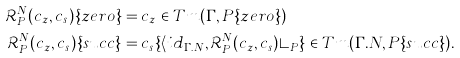<formula> <loc_0><loc_0><loc_500><loc_500>\mathcal { R } ^ { N } _ { P } ( c _ { z } , c _ { s } ) \{ z e r o \} & = c _ { z } \in T m ( \Gamma , P \{ z e r o \} ) \\ \mathcal { R } ^ { N } _ { P } ( c _ { z } , c _ { s } ) \{ s u c c \} & = c _ { s } \{ \langle i d _ { \Gamma . N } , \mathcal { R } ^ { N } _ { P } ( c _ { z } , c _ { s } ) \rangle _ { P } \} \in T m ( \Gamma . N , P \{ s u c c \} ) .</formula> 